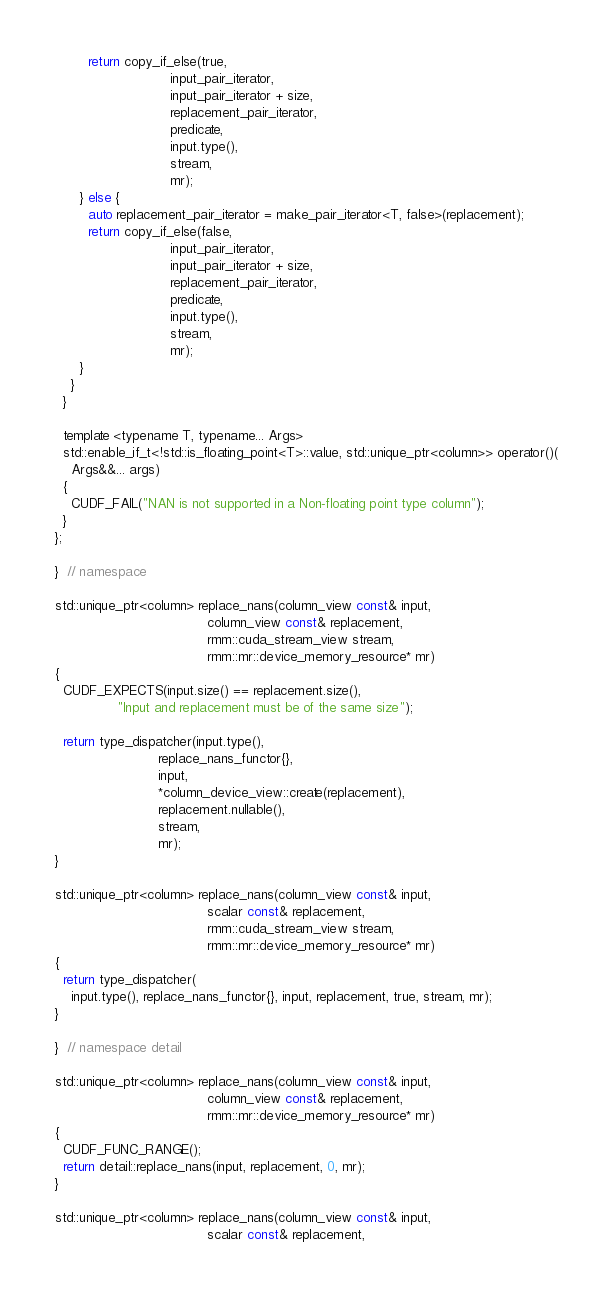<code> <loc_0><loc_0><loc_500><loc_500><_Cuda_>        return copy_if_else(true,
                            input_pair_iterator,
                            input_pair_iterator + size,
                            replacement_pair_iterator,
                            predicate,
                            input.type(),
                            stream,
                            mr);
      } else {
        auto replacement_pair_iterator = make_pair_iterator<T, false>(replacement);
        return copy_if_else(false,
                            input_pair_iterator,
                            input_pair_iterator + size,
                            replacement_pair_iterator,
                            predicate,
                            input.type(),
                            stream,
                            mr);
      }
    }
  }

  template <typename T, typename... Args>
  std::enable_if_t<!std::is_floating_point<T>::value, std::unique_ptr<column>> operator()(
    Args&&... args)
  {
    CUDF_FAIL("NAN is not supported in a Non-floating point type column");
  }
};

}  // namespace

std::unique_ptr<column> replace_nans(column_view const& input,
                                     column_view const& replacement,
                                     rmm::cuda_stream_view stream,
                                     rmm::mr::device_memory_resource* mr)
{
  CUDF_EXPECTS(input.size() == replacement.size(),
               "Input and replacement must be of the same size");

  return type_dispatcher(input.type(),
                         replace_nans_functor{},
                         input,
                         *column_device_view::create(replacement),
                         replacement.nullable(),
                         stream,
                         mr);
}

std::unique_ptr<column> replace_nans(column_view const& input,
                                     scalar const& replacement,
                                     rmm::cuda_stream_view stream,
                                     rmm::mr::device_memory_resource* mr)
{
  return type_dispatcher(
    input.type(), replace_nans_functor{}, input, replacement, true, stream, mr);
}

}  // namespace detail

std::unique_ptr<column> replace_nans(column_view const& input,
                                     column_view const& replacement,
                                     rmm::mr::device_memory_resource* mr)
{
  CUDF_FUNC_RANGE();
  return detail::replace_nans(input, replacement, 0, mr);
}

std::unique_ptr<column> replace_nans(column_view const& input,
                                     scalar const& replacement,</code> 